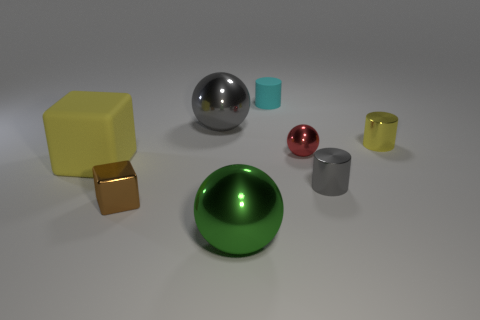Add 2 big purple rubber balls. How many objects exist? 10 Subtract all cylinders. How many objects are left? 5 Subtract all big cyan rubber spheres. Subtract all rubber things. How many objects are left? 6 Add 8 tiny cyan matte cylinders. How many tiny cyan matte cylinders are left? 9 Add 5 big green matte cylinders. How many big green matte cylinders exist? 5 Subtract 0 purple cubes. How many objects are left? 8 